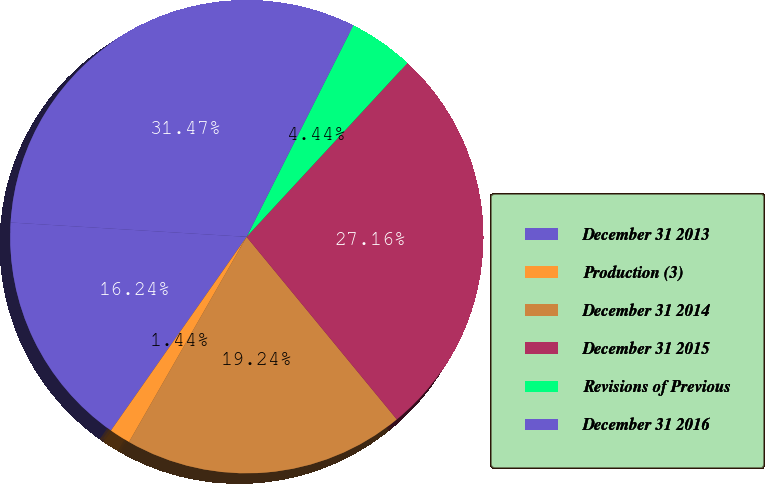Convert chart. <chart><loc_0><loc_0><loc_500><loc_500><pie_chart><fcel>December 31 2013<fcel>Production (3)<fcel>December 31 2014<fcel>December 31 2015<fcel>Revisions of Previous<fcel>December 31 2016<nl><fcel>16.24%<fcel>1.44%<fcel>19.24%<fcel>27.16%<fcel>4.44%<fcel>31.47%<nl></chart> 